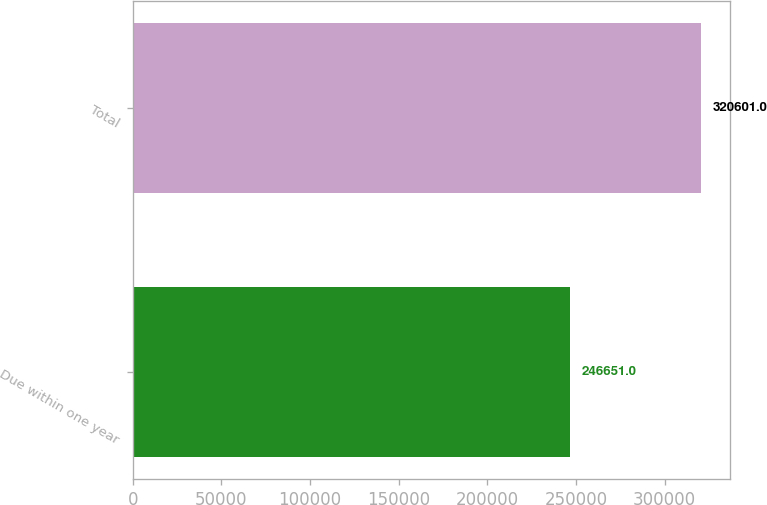<chart> <loc_0><loc_0><loc_500><loc_500><bar_chart><fcel>Due within one year<fcel>Total<nl><fcel>246651<fcel>320601<nl></chart> 